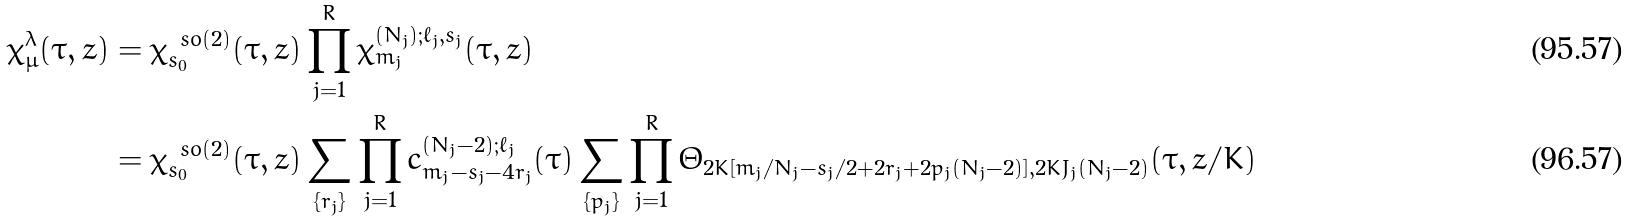<formula> <loc_0><loc_0><loc_500><loc_500>\chi ^ { \lambda } _ { \mu } ( \tau , z ) & = \chi ^ { \ s o ( 2 ) } _ { s _ { 0 } } ( \tau , z ) \prod _ { j = 1 } ^ { R } \chi ^ { ( N _ { j } ) ; \ell _ { j } , s _ { j } } _ { m _ { j } } ( \tau , z ) \\ & = \chi ^ { \ s o ( 2 ) } _ { s _ { 0 } } ( \tau , z ) \sum _ { \{ r _ { j } \} } \prod _ { j = 1 } ^ { R } c ^ { ( N _ { j } - 2 ) ; \ell _ { j } } _ { m _ { j } - s _ { j } - 4 r _ { j } } ( \tau ) \sum _ { \{ p _ { j } \} } \prod _ { j = 1 } ^ { R } \Theta _ { 2 K [ m _ { j } / N _ { j } - s _ { j } / 2 + 2 r _ { j } + 2 p _ { j } ( N _ { j } - 2 ) ] , 2 K J _ { j } ( N _ { j } - 2 ) } ( \tau , z / K )</formula> 